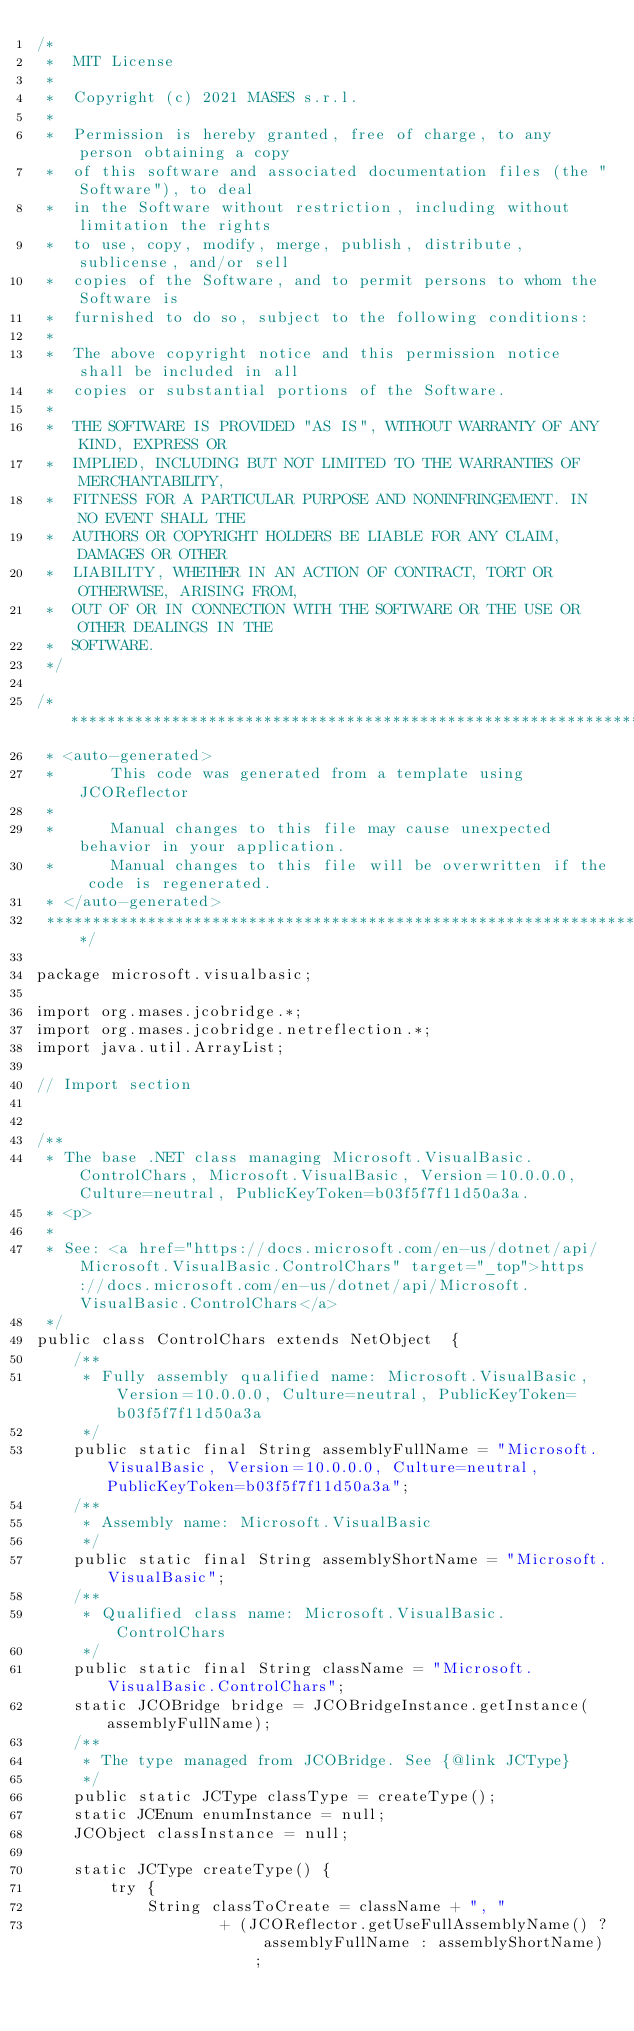Convert code to text. <code><loc_0><loc_0><loc_500><loc_500><_Java_>/*
 *  MIT License
 *
 *  Copyright (c) 2021 MASES s.r.l.
 *
 *  Permission is hereby granted, free of charge, to any person obtaining a copy
 *  of this software and associated documentation files (the "Software"), to deal
 *  in the Software without restriction, including without limitation the rights
 *  to use, copy, modify, merge, publish, distribute, sublicense, and/or sell
 *  copies of the Software, and to permit persons to whom the Software is
 *  furnished to do so, subject to the following conditions:
 *
 *  The above copyright notice and this permission notice shall be included in all
 *  copies or substantial portions of the Software.
 *
 *  THE SOFTWARE IS PROVIDED "AS IS", WITHOUT WARRANTY OF ANY KIND, EXPRESS OR
 *  IMPLIED, INCLUDING BUT NOT LIMITED TO THE WARRANTIES OF MERCHANTABILITY,
 *  FITNESS FOR A PARTICULAR PURPOSE AND NONINFRINGEMENT. IN NO EVENT SHALL THE
 *  AUTHORS OR COPYRIGHT HOLDERS BE LIABLE FOR ANY CLAIM, DAMAGES OR OTHER
 *  LIABILITY, WHETHER IN AN ACTION OF CONTRACT, TORT OR OTHERWISE, ARISING FROM,
 *  OUT OF OR IN CONNECTION WITH THE SOFTWARE OR THE USE OR OTHER DEALINGS IN THE
 *  SOFTWARE.
 */

/**************************************************************************************
 * <auto-generated>
 *      This code was generated from a template using JCOReflector
 * 
 *      Manual changes to this file may cause unexpected behavior in your application.
 *      Manual changes to this file will be overwritten if the code is regenerated.
 * </auto-generated>
 *************************************************************************************/

package microsoft.visualbasic;

import org.mases.jcobridge.*;
import org.mases.jcobridge.netreflection.*;
import java.util.ArrayList;

// Import section


/**
 * The base .NET class managing Microsoft.VisualBasic.ControlChars, Microsoft.VisualBasic, Version=10.0.0.0, Culture=neutral, PublicKeyToken=b03f5f7f11d50a3a.
 * <p>
 * 
 * See: <a href="https://docs.microsoft.com/en-us/dotnet/api/Microsoft.VisualBasic.ControlChars" target="_top">https://docs.microsoft.com/en-us/dotnet/api/Microsoft.VisualBasic.ControlChars</a>
 */
public class ControlChars extends NetObject  {
    /**
     * Fully assembly qualified name: Microsoft.VisualBasic, Version=10.0.0.0, Culture=neutral, PublicKeyToken=b03f5f7f11d50a3a
     */
    public static final String assemblyFullName = "Microsoft.VisualBasic, Version=10.0.0.0, Culture=neutral, PublicKeyToken=b03f5f7f11d50a3a";
    /**
     * Assembly name: Microsoft.VisualBasic
     */
    public static final String assemblyShortName = "Microsoft.VisualBasic";
    /**
     * Qualified class name: Microsoft.VisualBasic.ControlChars
     */
    public static final String className = "Microsoft.VisualBasic.ControlChars";
    static JCOBridge bridge = JCOBridgeInstance.getInstance(assemblyFullName);
    /**
     * The type managed from JCOBridge. See {@link JCType}
     */
    public static JCType classType = createType();
    static JCEnum enumInstance = null;
    JCObject classInstance = null;

    static JCType createType() {
        try {
            String classToCreate = className + ", "
                    + (JCOReflector.getUseFullAssemblyName() ? assemblyFullName : assemblyShortName);</code> 